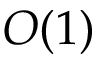Convert formula to latex. <formula><loc_0><loc_0><loc_500><loc_500>O ( 1 )</formula> 